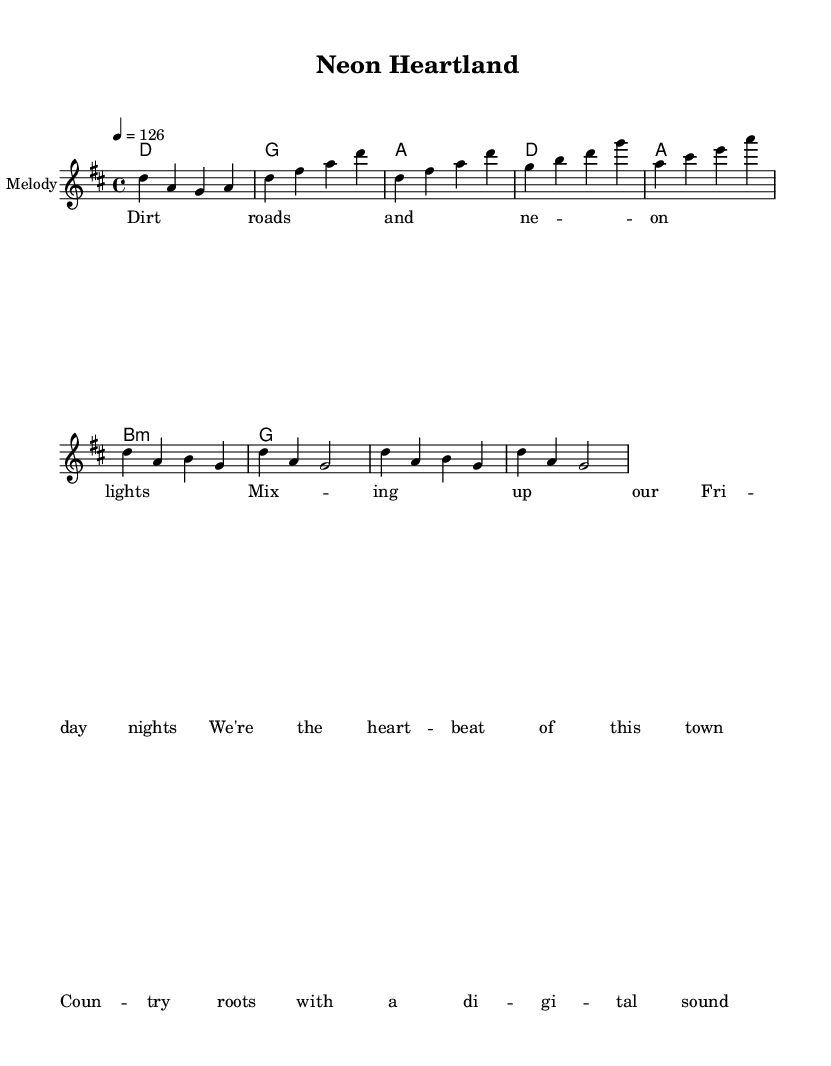What is the key signature of this music? The key signature is D major, which has two sharps: F# and C#. This is indicated at the beginning of the staff.
Answer: D major What is the time signature of this piece? The time signature is 4/4, which is indicated at the start of the sheet music. This means there are four beats in each measure, and the quarter note gets one beat.
Answer: 4/4 What is the tempo marking for this piece? The tempo marking is 126 beats per minute, which is indicated by the term “4 = 126” in the score. This specifies how fast the music should be played.
Answer: 126 How many measures are in the chorus section? The chorus consists of four measures, with the specific patterns laid out in the melodyChorus section of the score. Each measure is indicated by vertical bar lines.
Answer: 4 What type of chords are used in the song? The chord progression includes major, minor, and one suspended chord, specifically D, G, A, and B minor. This combination is characteristic of country rock's harmonic structure.
Answer: Major and minor What is the mood conveyed by the lyrics in this piece? The lyrics depict a joyous and celebratory mood, reflecting themes of community and modern life with a digital twist. This is a common characteristic in contemporary country rock.
Answer: Joyous What unique feature does this sheet music have compared to traditional country music? This piece incorporates electronic influences, evident in the lyrics that mention "digital sound," blending country traditional elements with modern electronic aesthetics. This feature signifies a contemporary evolution in the genre.
Answer: Electronic influences 